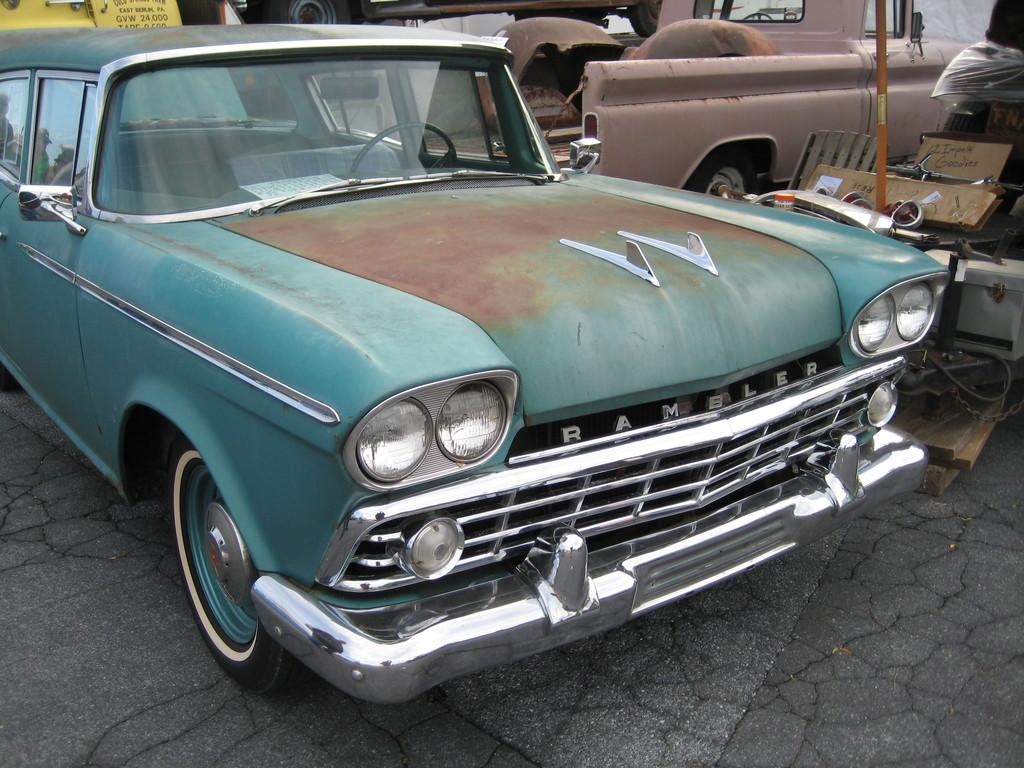What type of vehicles are on the ground in the image? There are cars on the ground in the image. What structure can be seen in the image? There is a pole in the image. What type of signage is present in the image? There are boards with text in the image. What type of furniture is in the image? There is a chair in the image. What type of architectural feature is present in the image? There is a wall in the image. What type of prison can be seen in the image? There is no prison present in the image. How much does the quarter-sized canvas cost in the image? There is no canvas or mention of a quarter in the image. 